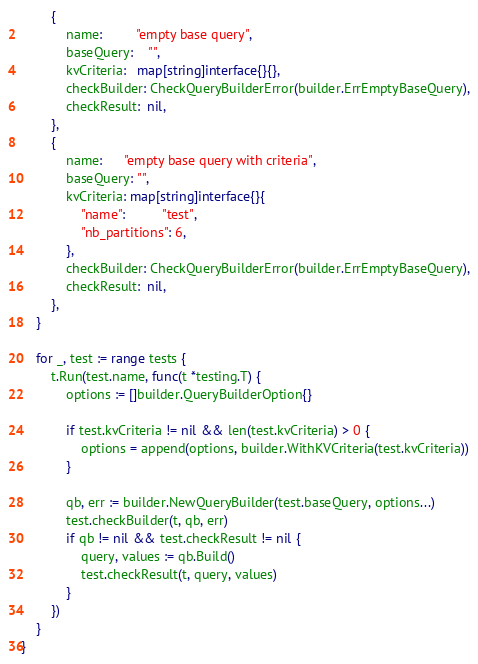<code> <loc_0><loc_0><loc_500><loc_500><_Go_>		{
			name:         "empty base query",
			baseQuery:    "",
			kvCriteria:   map[string]interface{}{},
			checkBuilder: CheckQueryBuilderError(builder.ErrEmptyBaseQuery),
			checkResult:  nil,
		},
		{
			name:      "empty base query with criteria",
			baseQuery: "",
			kvCriteria: map[string]interface{}{
				"name":          "test",
				"nb_partitions": 6,
			},
			checkBuilder: CheckQueryBuilderError(builder.ErrEmptyBaseQuery),
			checkResult:  nil,
		},
	}

	for _, test := range tests {
		t.Run(test.name, func(t *testing.T) {
			options := []builder.QueryBuilderOption{}

			if test.kvCriteria != nil && len(test.kvCriteria) > 0 {
				options = append(options, builder.WithKVCriteria(test.kvCriteria))
			}

			qb, err := builder.NewQueryBuilder(test.baseQuery, options...)
			test.checkBuilder(t, qb, err)
			if qb != nil && test.checkResult != nil {
				query, values := qb.Build()
				test.checkResult(t, query, values)
			}
		})
	}
}
</code> 